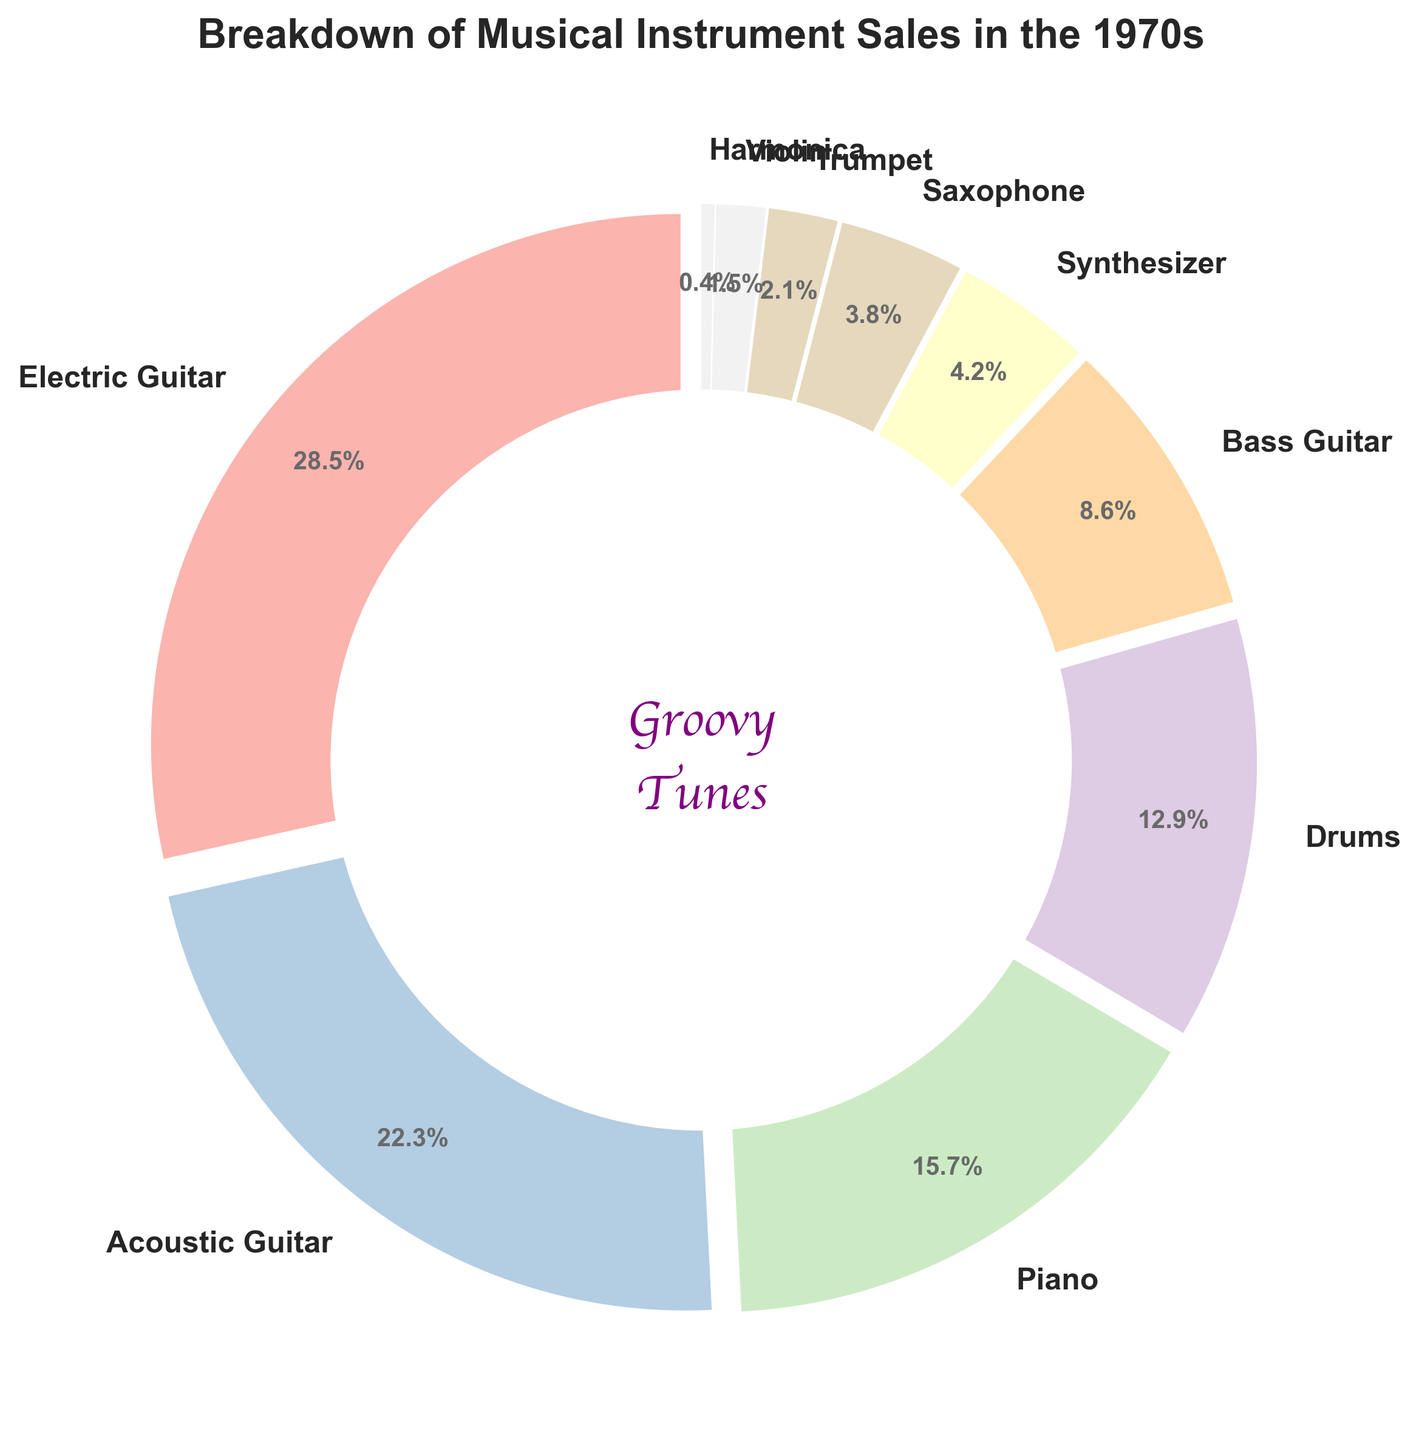What is the most sold musical instrument type? Looking at the pie chart, the segment for Electric Guitar is the largest, indicating it has the highest percentage of sales.
Answer: Electric Guitar Which instrument type has the least sales? The smallest wedge in the pie chart represents Harmonica, indicating it has the lowest percentage of sales.
Answer: Harmonica How much more did Electric Guitar sell compared to Saxophone? Electric Guitar sold 28.5% and Saxophone sold 3.8%. Subtracting Saxophone's sales from Electric Guitar's gives 28.5% - 3.8% = 24.7%.
Answer: 24.7% What is the total percentage of sales for electric and acoustic guitars combined? The percentage for Electric Guitar is 28.5% and for Acoustic Guitar is 22.3%. Adding these together gives 28.5% + 22.3% = 50.8%.
Answer: 50.8% Which instrument category has sales closest to 10%? The pie chart shows that Drums have a percentage of 12.9%, which is closest to 10% among all types.
Answer: Drums What is the combined percentage of sales for Drums, Synthesizers, and Pianos? Drums have 12.9%, Synthesizers have 4.2%, and Pianos have 15.7%. Adding them together gives 12.9% + 4.2% + 15.7% = 32.8%.
Answer: 32.8% How do the sales of Trumpets compare to those of Violins? The pie chart indicates that Trumpets have a percentage of 2.1%, whereas Violins have 1.5%. Comparatively, Trumpets have a higher percentage than Violins.
Answer: Trumpets have higher sales Name two instrument categories that, when combined, represent over 50% of the total sales. Electric Guitar (28.5%) and Acoustic Guitar (22.3%) together add up to 50.8%, which is over 50%.
Answer: Electric Guitar and Acoustic Guitar Which instrument is the fourth most sold according to the chart? The pie chart shows that Drums have 12.9% of sales, making it the fourth most sold instrument.
Answer: Drums If you exclude Electric Guitar sales, which instrument category has the next highest sales? Without considering Electric Guitar sales (28.5%), Acoustic Guitar has the next highest sales at 22.3%.
Answer: Acoustic Guitar 